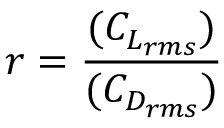<formula> <loc_0><loc_0><loc_500><loc_500>r = \frac { ( C _ { L _ { r m s } } ) } { ( C _ { D _ { r m s } } ) }</formula> 